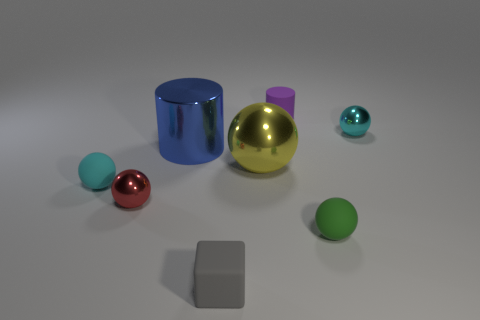Which objects in the image appear to be the largest and the smallest? In the image, the large gold sphere appears to be the largest object, while the smallest objects are the two smallest spheres with a matte finish, one of which is purple and the other is green. 